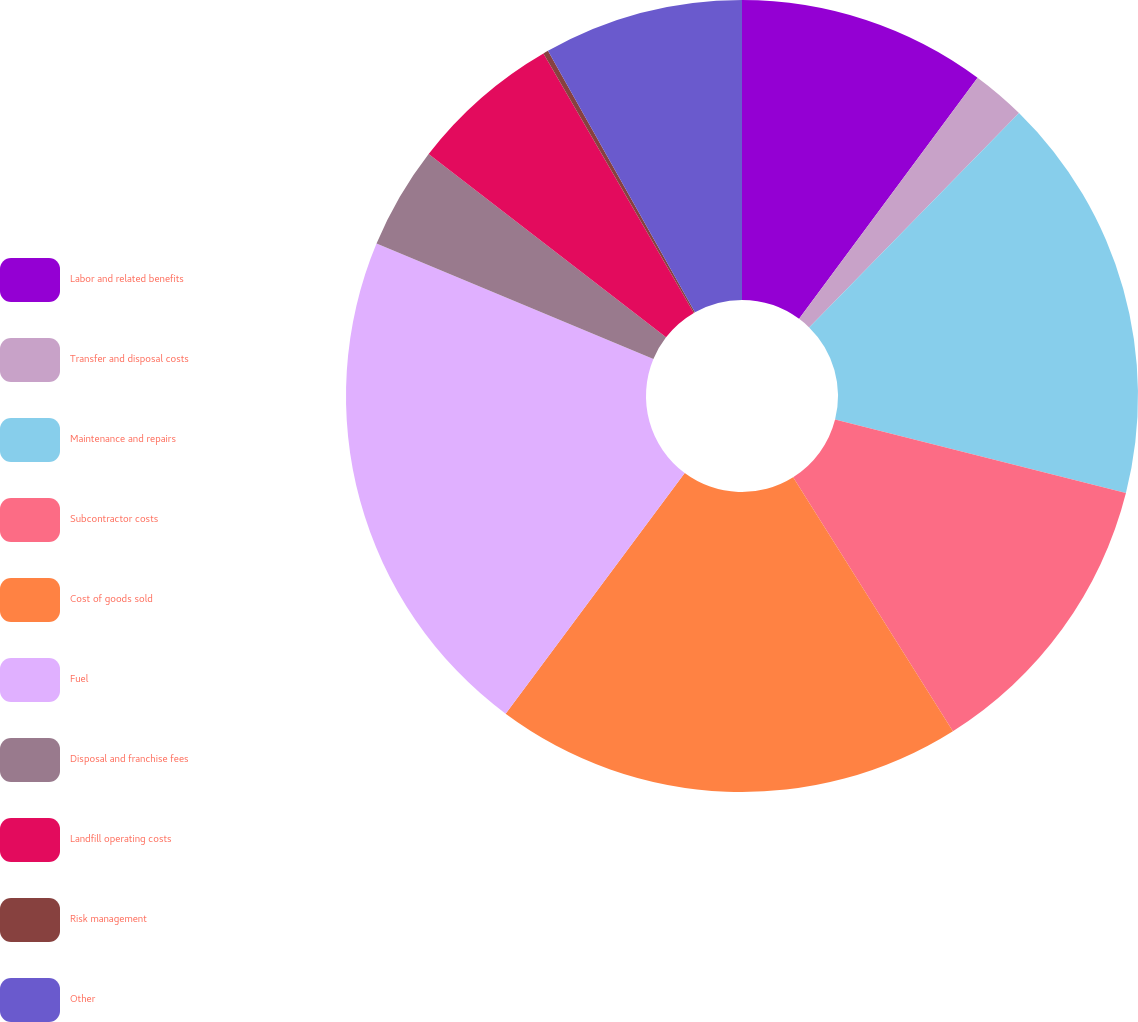Convert chart. <chart><loc_0><loc_0><loc_500><loc_500><pie_chart><fcel>Labor and related benefits<fcel>Transfer and disposal costs<fcel>Maintenance and repairs<fcel>Subcontractor costs<fcel>Cost of goods sold<fcel>Fuel<fcel>Disposal and franchise fees<fcel>Landfill operating costs<fcel>Risk management<fcel>Other<nl><fcel>10.14%<fcel>2.19%<fcel>16.61%<fcel>12.12%<fcel>19.12%<fcel>21.11%<fcel>4.18%<fcel>6.17%<fcel>0.21%<fcel>8.15%<nl></chart> 